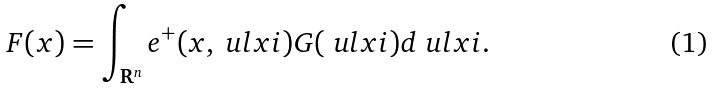Convert formula to latex. <formula><loc_0><loc_0><loc_500><loc_500>F ( x ) & = \int _ { \mathbf R ^ { n } } e ^ { + } ( x , \ u l x i ) G ( \ u l x i ) d \ u l x i .</formula> 